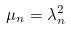Convert formula to latex. <formula><loc_0><loc_0><loc_500><loc_500>\mu _ { n } = \lambda _ { n } ^ { 2 }</formula> 